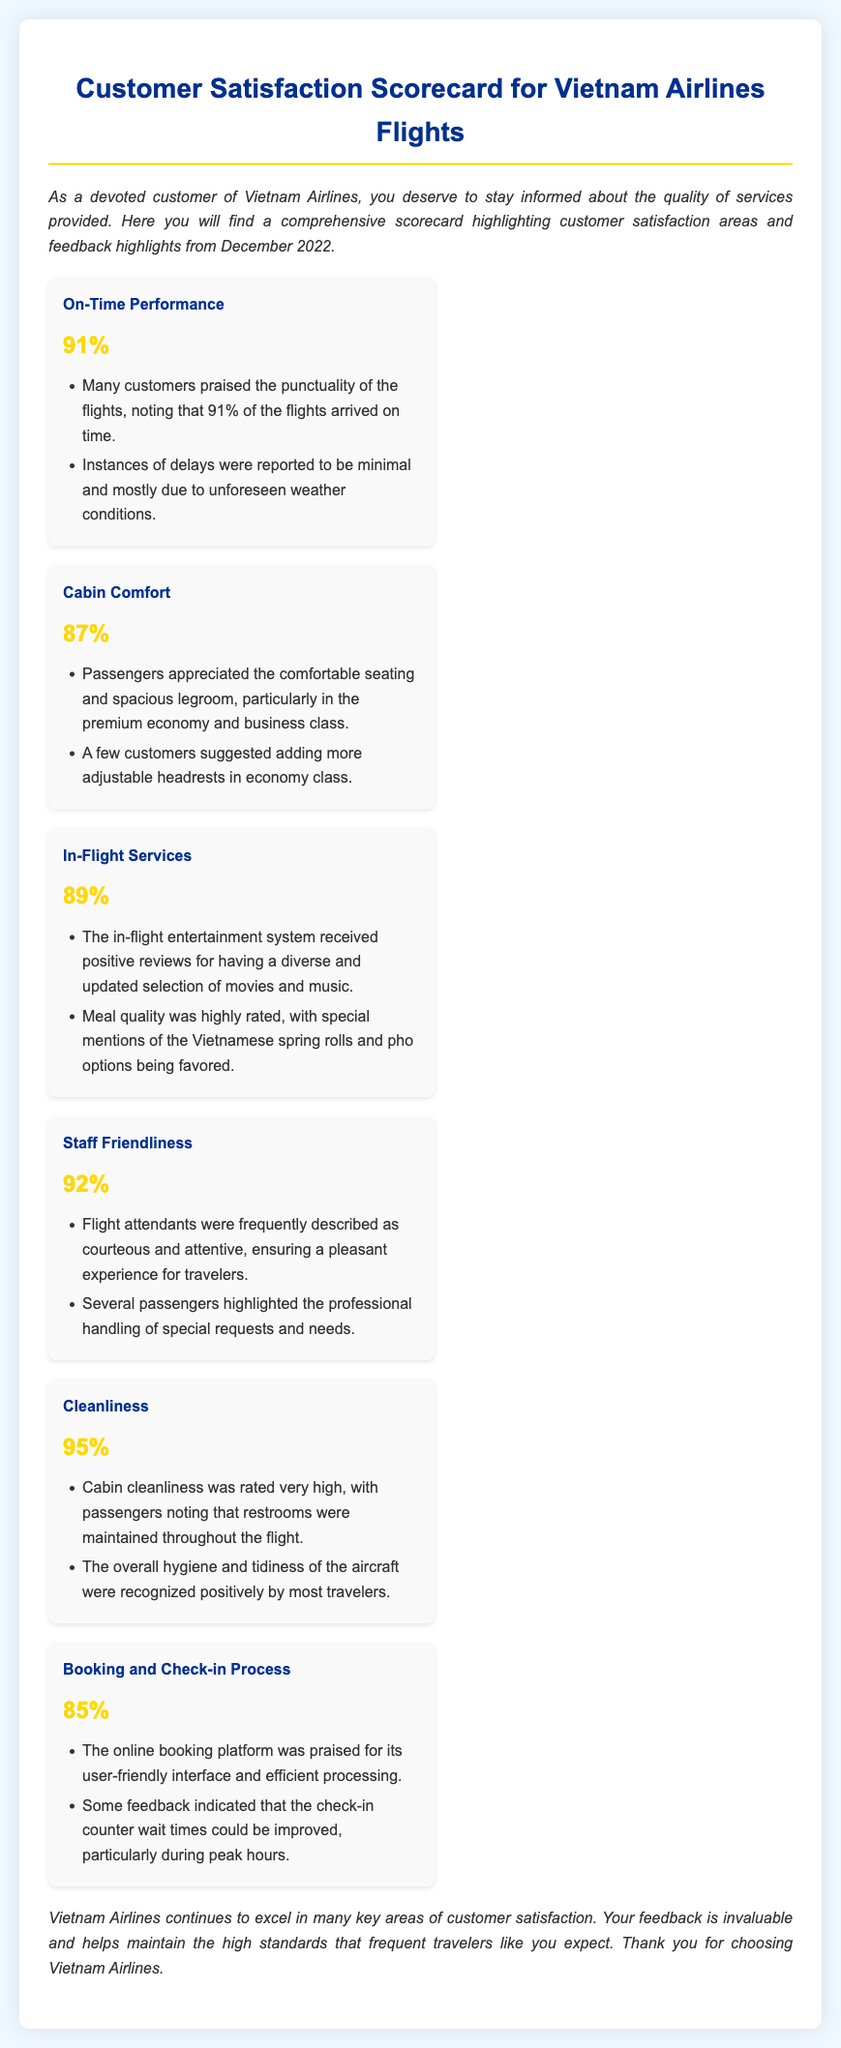What is the On-Time Performance percentage? The On-Time Performance percentage is specified in the document under the relevant aspect, which states that 91% of the flights arrived on time.
Answer: 91% What aspect has the highest rating? The ratings for each aspect are listed in the scorecard; Cleanliness has the highest rating at 95%.
Answer: 95% What feedback was given regarding Cabin Comfort? Feedback highlights regarding Cabin Comfort mention the comfortable seating and spacious legroom, with a suggestion for more adjustable headrests.
Answer: Comfortable seating and spacious legroom How did passengers rate In-Flight Services? The rating of In-Flight Services is provided in the document, showing a customer satisfaction score of 89%.
Answer: 89% What were passengers' comments about Staff Friendliness? Passengers frequently expressed that flight attendants were courteous and attentive, which indicates high satisfaction in this area.
Answer: Courteous and attentive What was mentioned about the Booking and Check-in Process feedback? The feedback states that the online booking platform was praised, but check-in counter wait times needed improvement during peak hours.
Answer: User-friendly interface What is the overall hygiene rating indicated in the Cleanliness aspect? The Cleanliness aspect highlights a very high rating, specifically noting that overall hygiene and tidiness were recognized positively.
Answer: Very high rating How many customers appreciated the punctuality of the flights? The document notes that many customers praised the punctuality, with 91% of flights arriving on time, indicating positive feedback regarding this aspect.
Answer: Many customers What was the rating for Cabin Comfort? The document lists the ratings for Cabin Comfort, showing a score of 87%.
Answer: 87% 